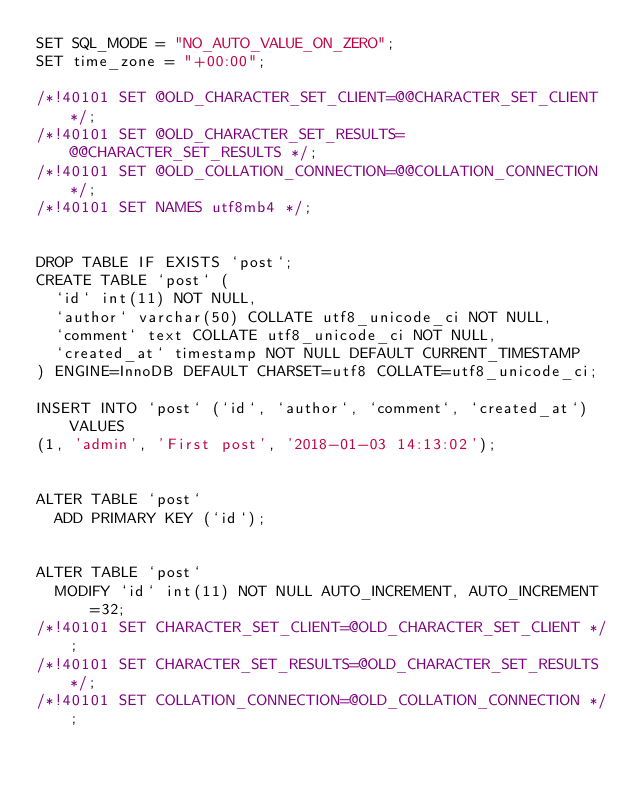Convert code to text. <code><loc_0><loc_0><loc_500><loc_500><_SQL_>SET SQL_MODE = "NO_AUTO_VALUE_ON_ZERO";
SET time_zone = "+00:00";

/*!40101 SET @OLD_CHARACTER_SET_CLIENT=@@CHARACTER_SET_CLIENT */;
/*!40101 SET @OLD_CHARACTER_SET_RESULTS=@@CHARACTER_SET_RESULTS */;
/*!40101 SET @OLD_COLLATION_CONNECTION=@@COLLATION_CONNECTION */;
/*!40101 SET NAMES utf8mb4 */;


DROP TABLE IF EXISTS `post`;
CREATE TABLE `post` (
  `id` int(11) NOT NULL,
  `author` varchar(50) COLLATE utf8_unicode_ci NOT NULL,
  `comment` text COLLATE utf8_unicode_ci NOT NULL,
  `created_at` timestamp NOT NULL DEFAULT CURRENT_TIMESTAMP
) ENGINE=InnoDB DEFAULT CHARSET=utf8 COLLATE=utf8_unicode_ci;

INSERT INTO `post` (`id`, `author`, `comment`, `created_at`) VALUES
(1, 'admin', 'First post', '2018-01-03 14:13:02');


ALTER TABLE `post`
  ADD PRIMARY KEY (`id`);


ALTER TABLE `post`
  MODIFY `id` int(11) NOT NULL AUTO_INCREMENT, AUTO_INCREMENT=32;
/*!40101 SET CHARACTER_SET_CLIENT=@OLD_CHARACTER_SET_CLIENT */;
/*!40101 SET CHARACTER_SET_RESULTS=@OLD_CHARACTER_SET_RESULTS */;
/*!40101 SET COLLATION_CONNECTION=@OLD_COLLATION_CONNECTION */;
</code> 